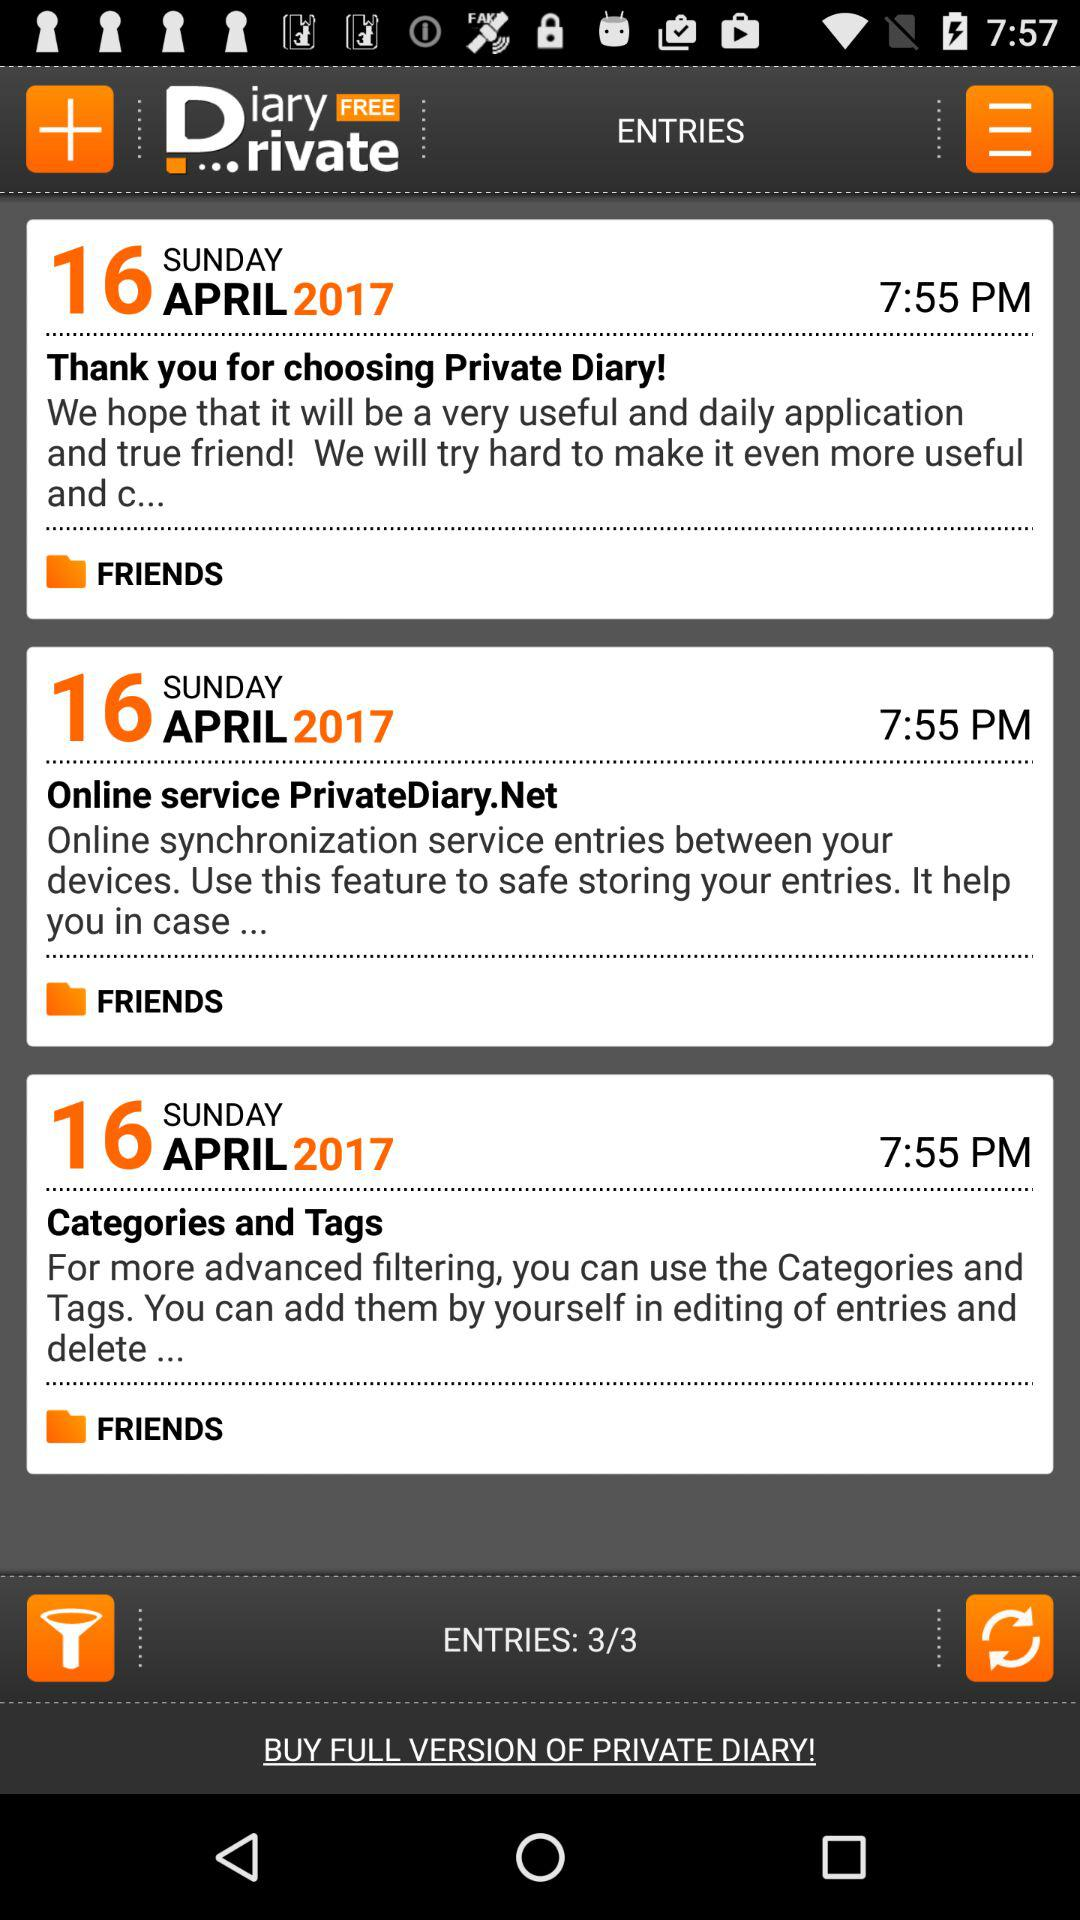At what time were the entries made? The entries were made at 7:55 PM. 